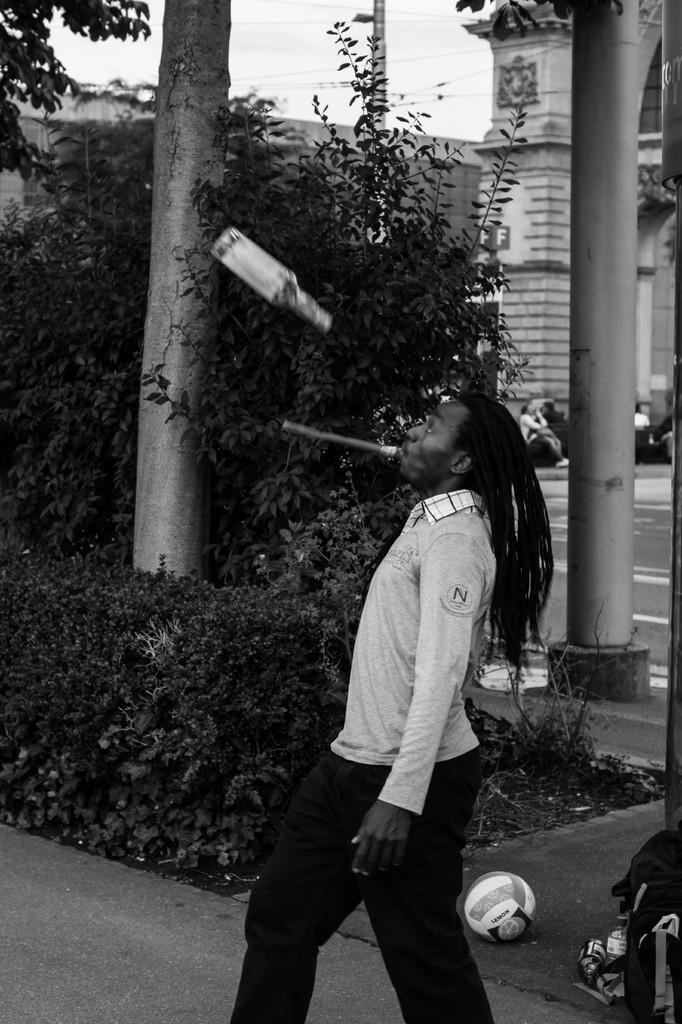Please provide a concise description of this image. This picture is in black and white. In the center, there is a man holding an object in the mouth. Before him, there is a bottle in the air. At the bottom, there is a ball and a bag. In the background, there are plants, trees, pillars, building and a sky. 